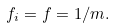<formula> <loc_0><loc_0><loc_500><loc_500>f _ { i } = f = 1 / m .</formula> 